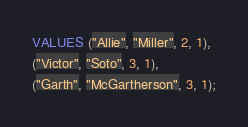Convert code to text. <code><loc_0><loc_0><loc_500><loc_500><_SQL_>VALUES ("Allie", "Miller", 2, 1),
("Victor", "Soto", 3, 1),
("Garth", "McGartherson", 3, 1);
</code> 